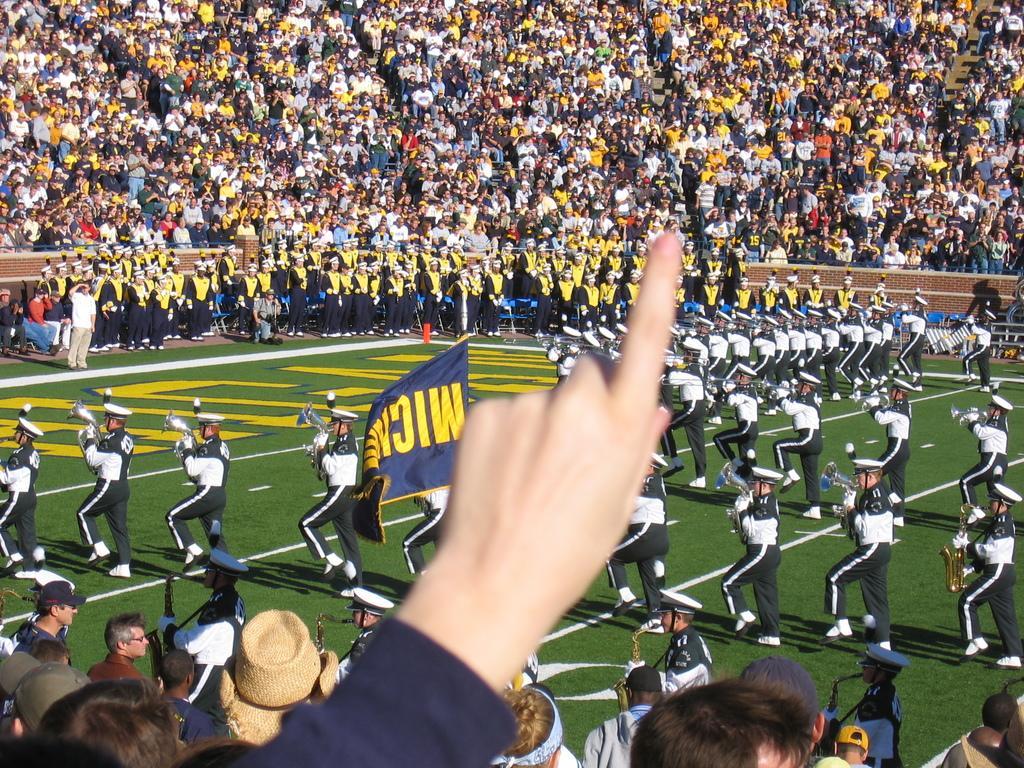Describe this image in one or two sentences. In this picture I can see a human hand at the bottom, in the middle a group of people are playing the musical instruments, at the top a lot of people are watching this activity from there. 